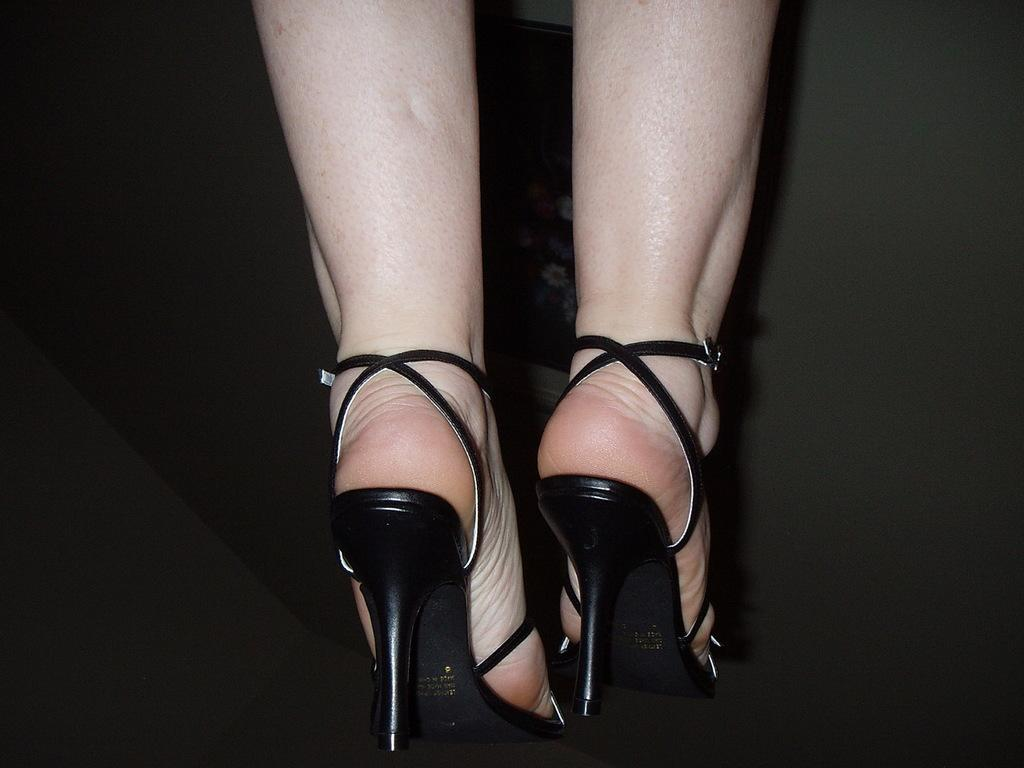What part of a person's body is visible in the image? There is a person's leg in the image. What type of footwear is the person wearing? The person is wearing heels. Can you describe the background of the image? The background of the image is dark. How many chickens are visible in the image? There are no chickens present in the image. What type of stem can be seen growing from the person's leg in the image? There is no stem visible in the image; only a person's leg and heels are present. 